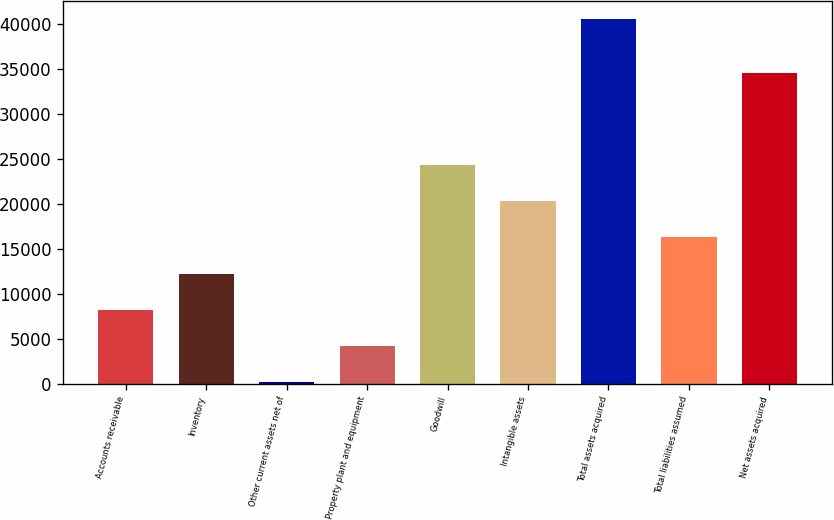<chart> <loc_0><loc_0><loc_500><loc_500><bar_chart><fcel>Accounts receivable<fcel>Inventory<fcel>Other current assets net of<fcel>Property plant and equipment<fcel>Goodwill<fcel>Intangible assets<fcel>Total assets acquired<fcel>Total liabilities assumed<fcel>Net assets acquired<nl><fcel>8200<fcel>12234.5<fcel>131<fcel>4165.5<fcel>24338<fcel>20303.5<fcel>40476<fcel>16269<fcel>34537<nl></chart> 